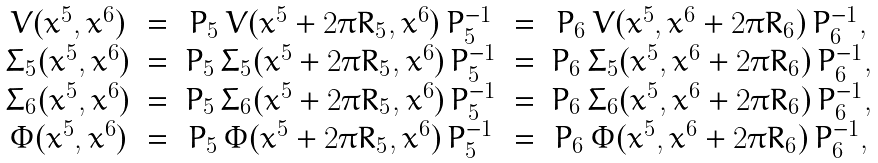<formula> <loc_0><loc_0><loc_500><loc_500>\begin{array} { c c c c c } V ( x ^ { 5 } , x ^ { 6 } ) & = & P _ { 5 } \, V ( x ^ { 5 } + 2 \pi R _ { 5 } , x ^ { 6 } ) \, P _ { 5 } ^ { - 1 } & = & P _ { 6 } \, V ( x ^ { 5 } , x ^ { 6 } + 2 \pi R _ { 6 } ) \, P _ { 6 } ^ { - 1 } , \\ \Sigma _ { 5 } ( x ^ { 5 } , x ^ { 6 } ) & = & P _ { 5 } \, \Sigma _ { 5 } ( x ^ { 5 } + 2 \pi R _ { 5 } , x ^ { 6 } ) \, P _ { 5 } ^ { - 1 } & = & P _ { 6 } \, \Sigma _ { 5 } ( x ^ { 5 } , x ^ { 6 } + 2 \pi R _ { 6 } ) \, P _ { 6 } ^ { - 1 } , \\ \Sigma _ { 6 } ( x ^ { 5 } , x ^ { 6 } ) & = & P _ { 5 } \, \Sigma _ { 6 } ( x ^ { 5 } + 2 \pi R _ { 5 } , x ^ { 6 } ) \, P _ { 5 } ^ { - 1 } & = & P _ { 6 } \, \Sigma _ { 6 } ( x ^ { 5 } , x ^ { 6 } + 2 \pi R _ { 6 } ) \, P _ { 6 } ^ { - 1 } , \\ \Phi ( x ^ { 5 } , x ^ { 6 } ) & = & P _ { 5 } \, \Phi ( x ^ { 5 } + 2 \pi R _ { 5 } , x ^ { 6 } ) \, P _ { 5 } ^ { - 1 } & = & P _ { 6 } \, \Phi ( x ^ { 5 } , x ^ { 6 } + 2 \pi R _ { 6 } ) \, P _ { 6 } ^ { - 1 } , \end{array}</formula> 